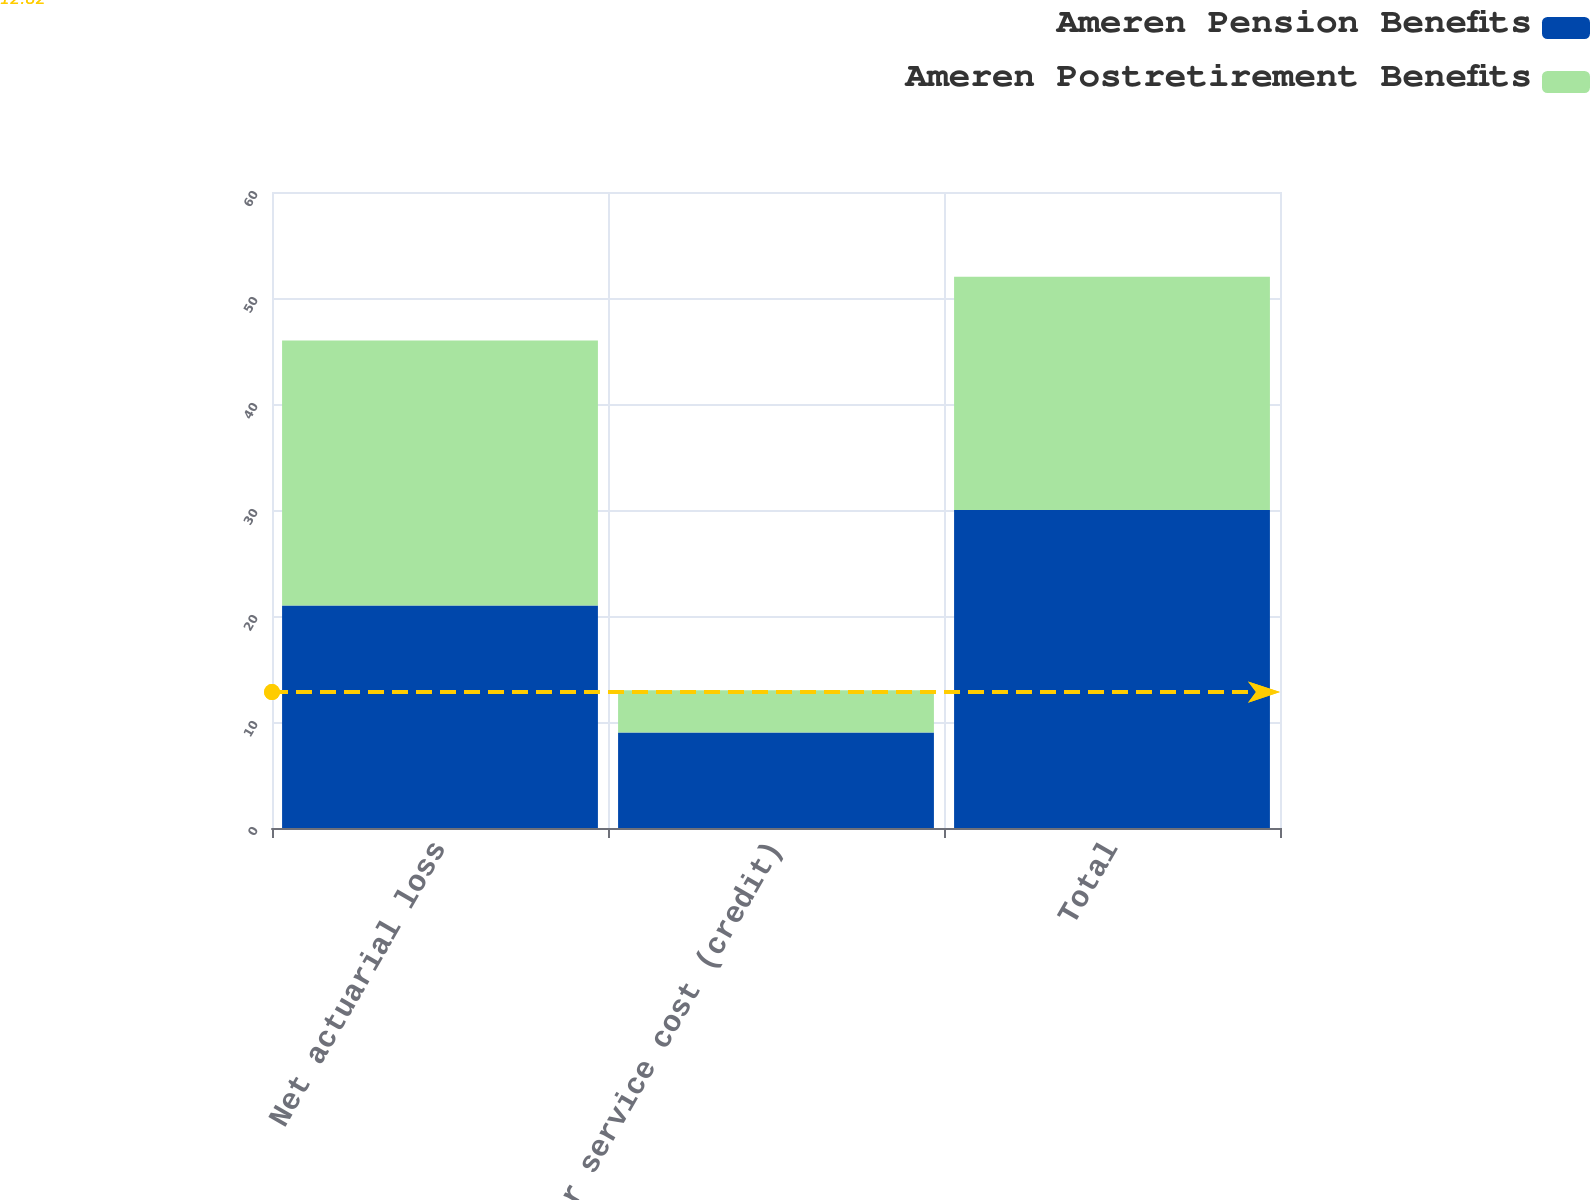Convert chart to OTSL. <chart><loc_0><loc_0><loc_500><loc_500><stacked_bar_chart><ecel><fcel>Net actuarial loss<fcel>Prior service cost (credit)<fcel>Total<nl><fcel>Ameren Pension Benefits<fcel>21<fcel>9<fcel>30<nl><fcel>Ameren Postretirement Benefits<fcel>25<fcel>4<fcel>22<nl></chart> 